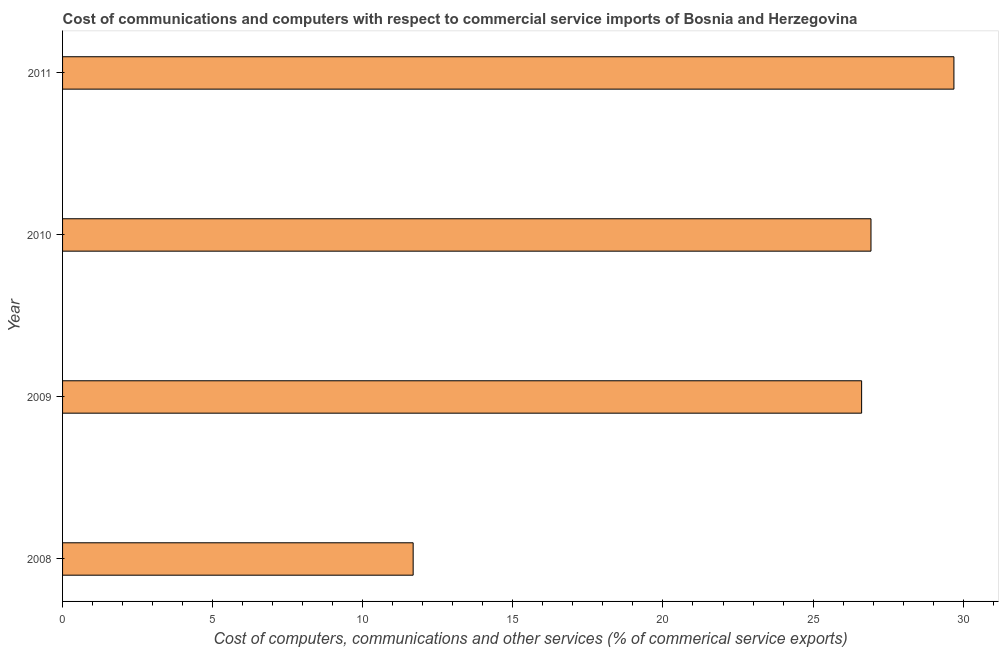Does the graph contain grids?
Your answer should be compact. No. What is the title of the graph?
Give a very brief answer. Cost of communications and computers with respect to commercial service imports of Bosnia and Herzegovina. What is the label or title of the X-axis?
Ensure brevity in your answer.  Cost of computers, communications and other services (% of commerical service exports). What is the  computer and other services in 2009?
Your response must be concise. 26.62. Across all years, what is the maximum cost of communications?
Your answer should be very brief. 29.69. Across all years, what is the minimum cost of communications?
Ensure brevity in your answer.  11.68. In which year was the cost of communications minimum?
Your response must be concise. 2008. What is the sum of the cost of communications?
Offer a very short reply. 94.92. What is the difference between the  computer and other services in 2008 and 2011?
Your answer should be very brief. -18.01. What is the average cost of communications per year?
Your answer should be very brief. 23.73. What is the median  computer and other services?
Your answer should be compact. 26.77. What is the ratio of the cost of communications in 2010 to that in 2011?
Your answer should be very brief. 0.91. Is the  computer and other services in 2009 less than that in 2010?
Provide a short and direct response. Yes. What is the difference between the highest and the second highest cost of communications?
Give a very brief answer. 2.76. What is the difference between the highest and the lowest cost of communications?
Offer a terse response. 18.01. How many bars are there?
Provide a succinct answer. 4. How many years are there in the graph?
Give a very brief answer. 4. Are the values on the major ticks of X-axis written in scientific E-notation?
Offer a terse response. No. What is the Cost of computers, communications and other services (% of commerical service exports) in 2008?
Provide a short and direct response. 11.68. What is the Cost of computers, communications and other services (% of commerical service exports) in 2009?
Keep it short and to the point. 26.62. What is the Cost of computers, communications and other services (% of commerical service exports) in 2010?
Give a very brief answer. 26.93. What is the Cost of computers, communications and other services (% of commerical service exports) in 2011?
Provide a short and direct response. 29.69. What is the difference between the Cost of computers, communications and other services (% of commerical service exports) in 2008 and 2009?
Keep it short and to the point. -14.94. What is the difference between the Cost of computers, communications and other services (% of commerical service exports) in 2008 and 2010?
Your answer should be compact. -15.25. What is the difference between the Cost of computers, communications and other services (% of commerical service exports) in 2008 and 2011?
Your answer should be very brief. -18.01. What is the difference between the Cost of computers, communications and other services (% of commerical service exports) in 2009 and 2010?
Ensure brevity in your answer.  -0.31. What is the difference between the Cost of computers, communications and other services (% of commerical service exports) in 2009 and 2011?
Ensure brevity in your answer.  -3.07. What is the difference between the Cost of computers, communications and other services (% of commerical service exports) in 2010 and 2011?
Ensure brevity in your answer.  -2.76. What is the ratio of the Cost of computers, communications and other services (% of commerical service exports) in 2008 to that in 2009?
Your answer should be compact. 0.44. What is the ratio of the Cost of computers, communications and other services (% of commerical service exports) in 2008 to that in 2010?
Keep it short and to the point. 0.43. What is the ratio of the Cost of computers, communications and other services (% of commerical service exports) in 2008 to that in 2011?
Keep it short and to the point. 0.39. What is the ratio of the Cost of computers, communications and other services (% of commerical service exports) in 2009 to that in 2010?
Offer a very short reply. 0.99. What is the ratio of the Cost of computers, communications and other services (% of commerical service exports) in 2009 to that in 2011?
Offer a very short reply. 0.9. What is the ratio of the Cost of computers, communications and other services (% of commerical service exports) in 2010 to that in 2011?
Your response must be concise. 0.91. 